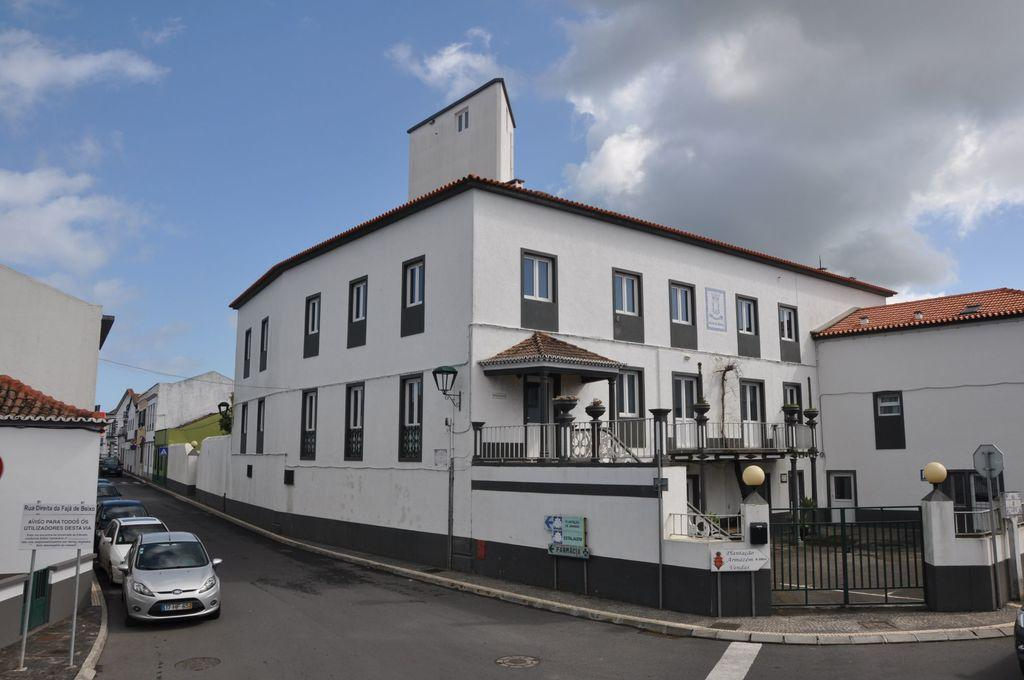What can be seen on the road in the image? There are vehicles on the road in the image. What type of structures are present in the image? There are buildings in the image. What objects can be seen near the buildings? There are boards and iron grilles in the image. What is visible in the background of the image? The sky is visible in the background of the image. Can you tell me how many times the hydrant sneezes in the image? There is no hydrant present in the image, and therefore no sneezing can be observed. What is the comparison between the buildings and the sneeze in the image? There is no sneeze present in the image, and thus no comparison can be made. 